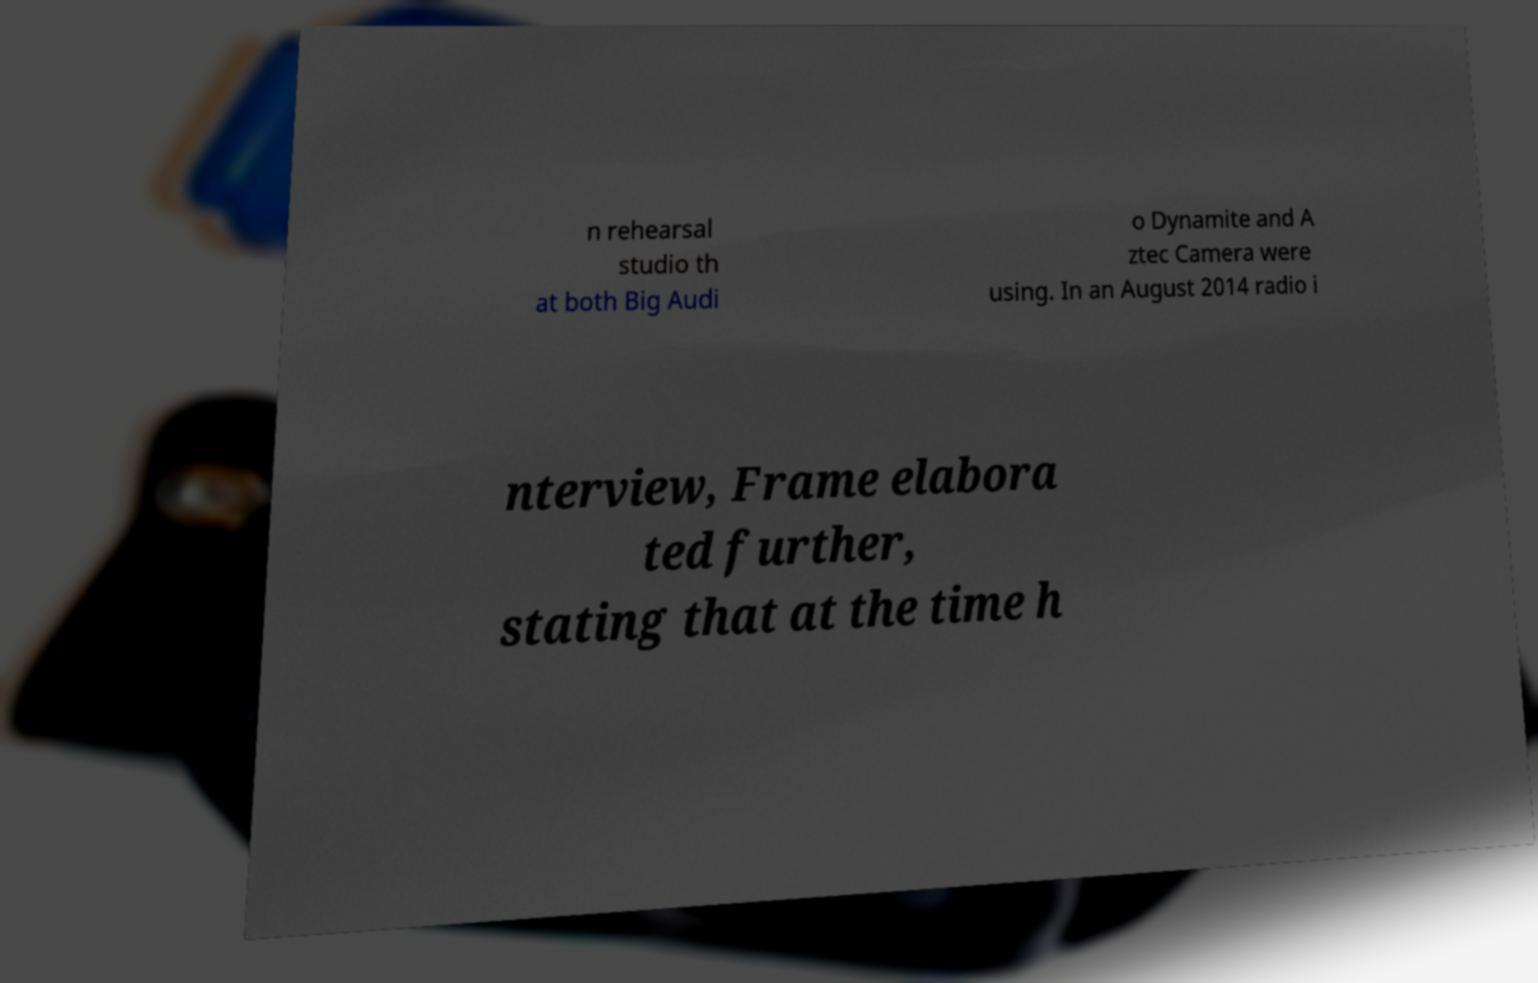Could you assist in decoding the text presented in this image and type it out clearly? n rehearsal studio th at both Big Audi o Dynamite and A ztec Camera were using. In an August 2014 radio i nterview, Frame elabora ted further, stating that at the time h 